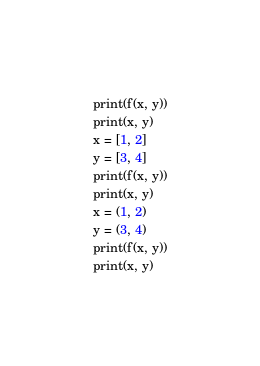<code> <loc_0><loc_0><loc_500><loc_500><_Python_>print(f(x, y))
print(x, y)
x = [1, 2]
y = [3, 4]
print(f(x, y))
print(x, y)
x = (1, 2)
y = (3, 4)
print(f(x, y))
print(x, y)
</code> 